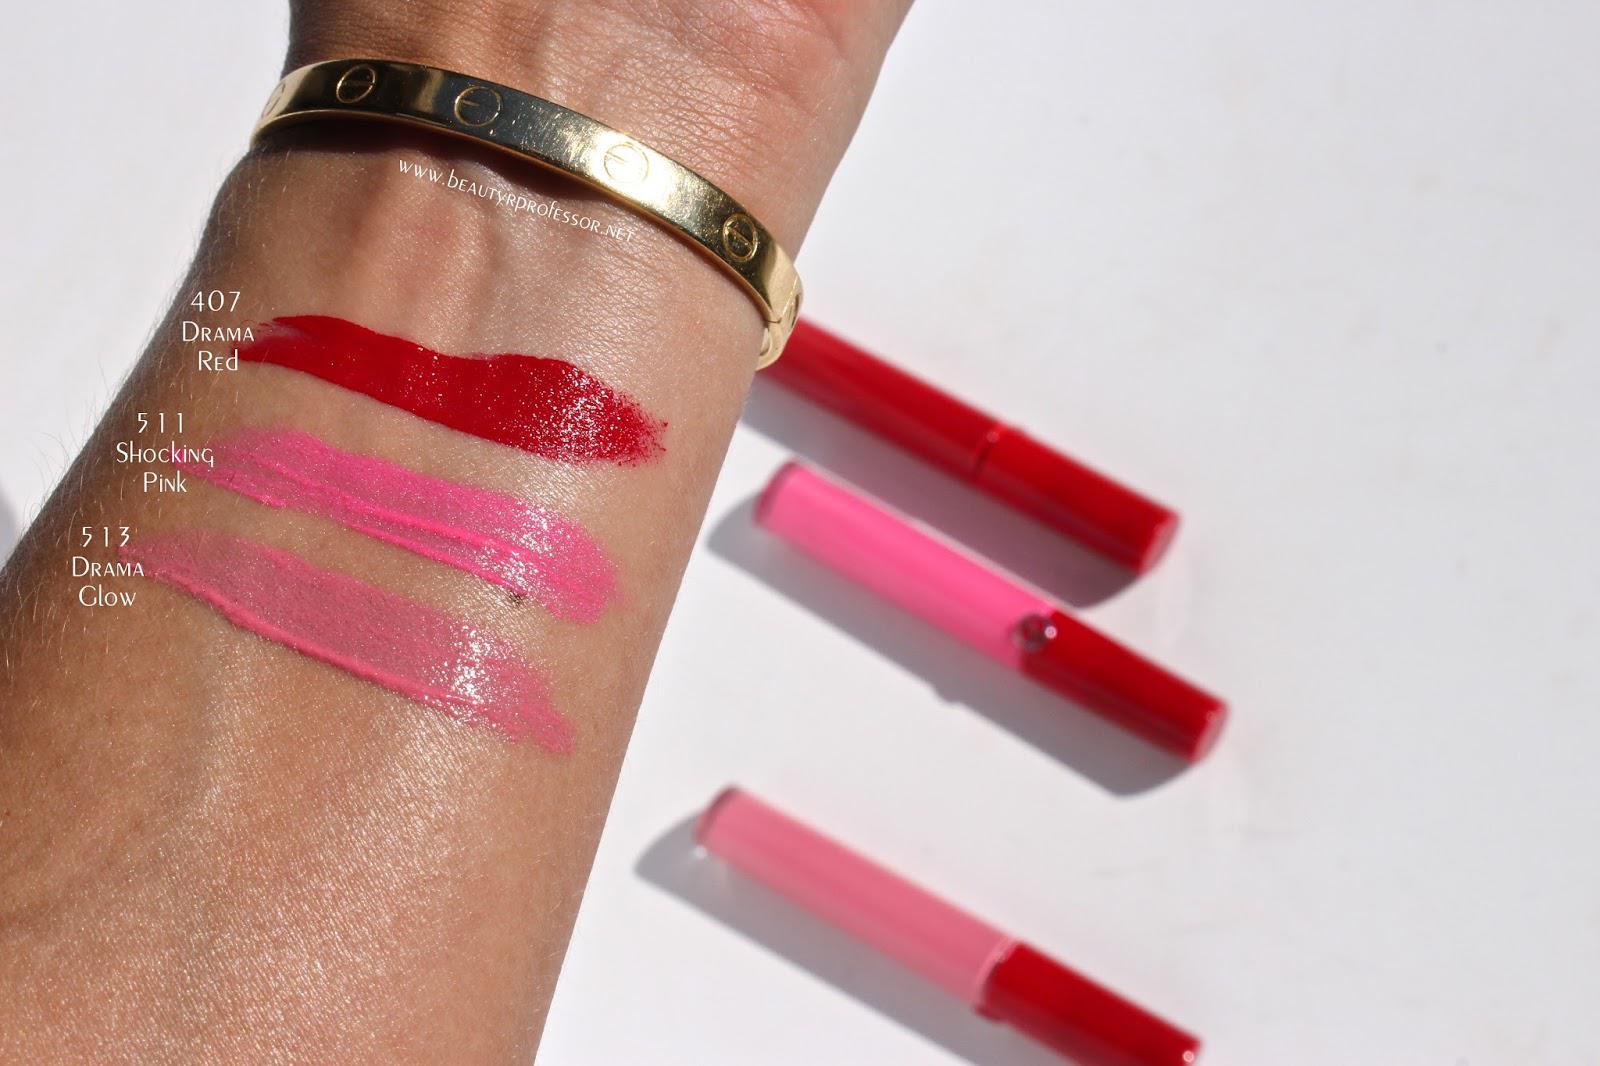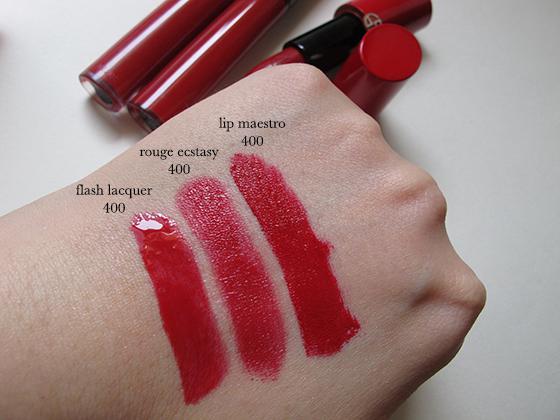The first image is the image on the left, the second image is the image on the right. Assess this claim about the two images: "One of the images does not have three stripes drawn onto skin.". Correct or not? Answer yes or no. No. The first image is the image on the left, the second image is the image on the right. Given the left and right images, does the statement "Each image shows skin with three lipstick sample stripes on it." hold true? Answer yes or no. Yes. 